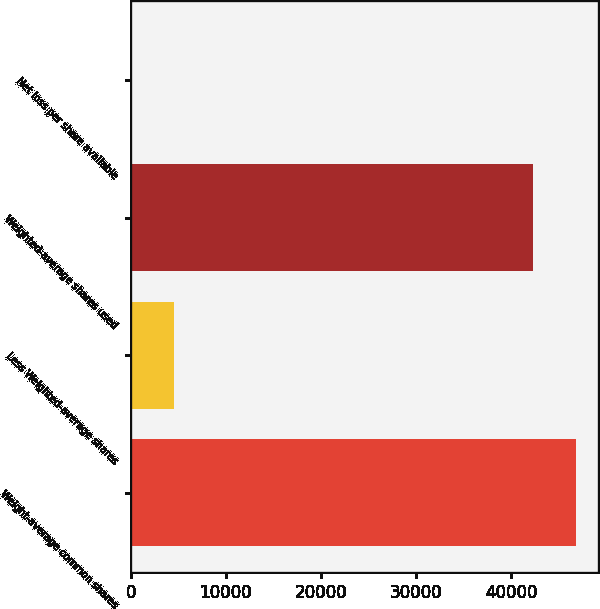Convert chart to OTSL. <chart><loc_0><loc_0><loc_500><loc_500><bar_chart><fcel>Weight-average common shares<fcel>Less Weighted-average shares<fcel>Weighted-average shares used<fcel>Net loss per share available<nl><fcel>46765.6<fcel>4521.25<fcel>42247<fcel>2.61<nl></chart> 